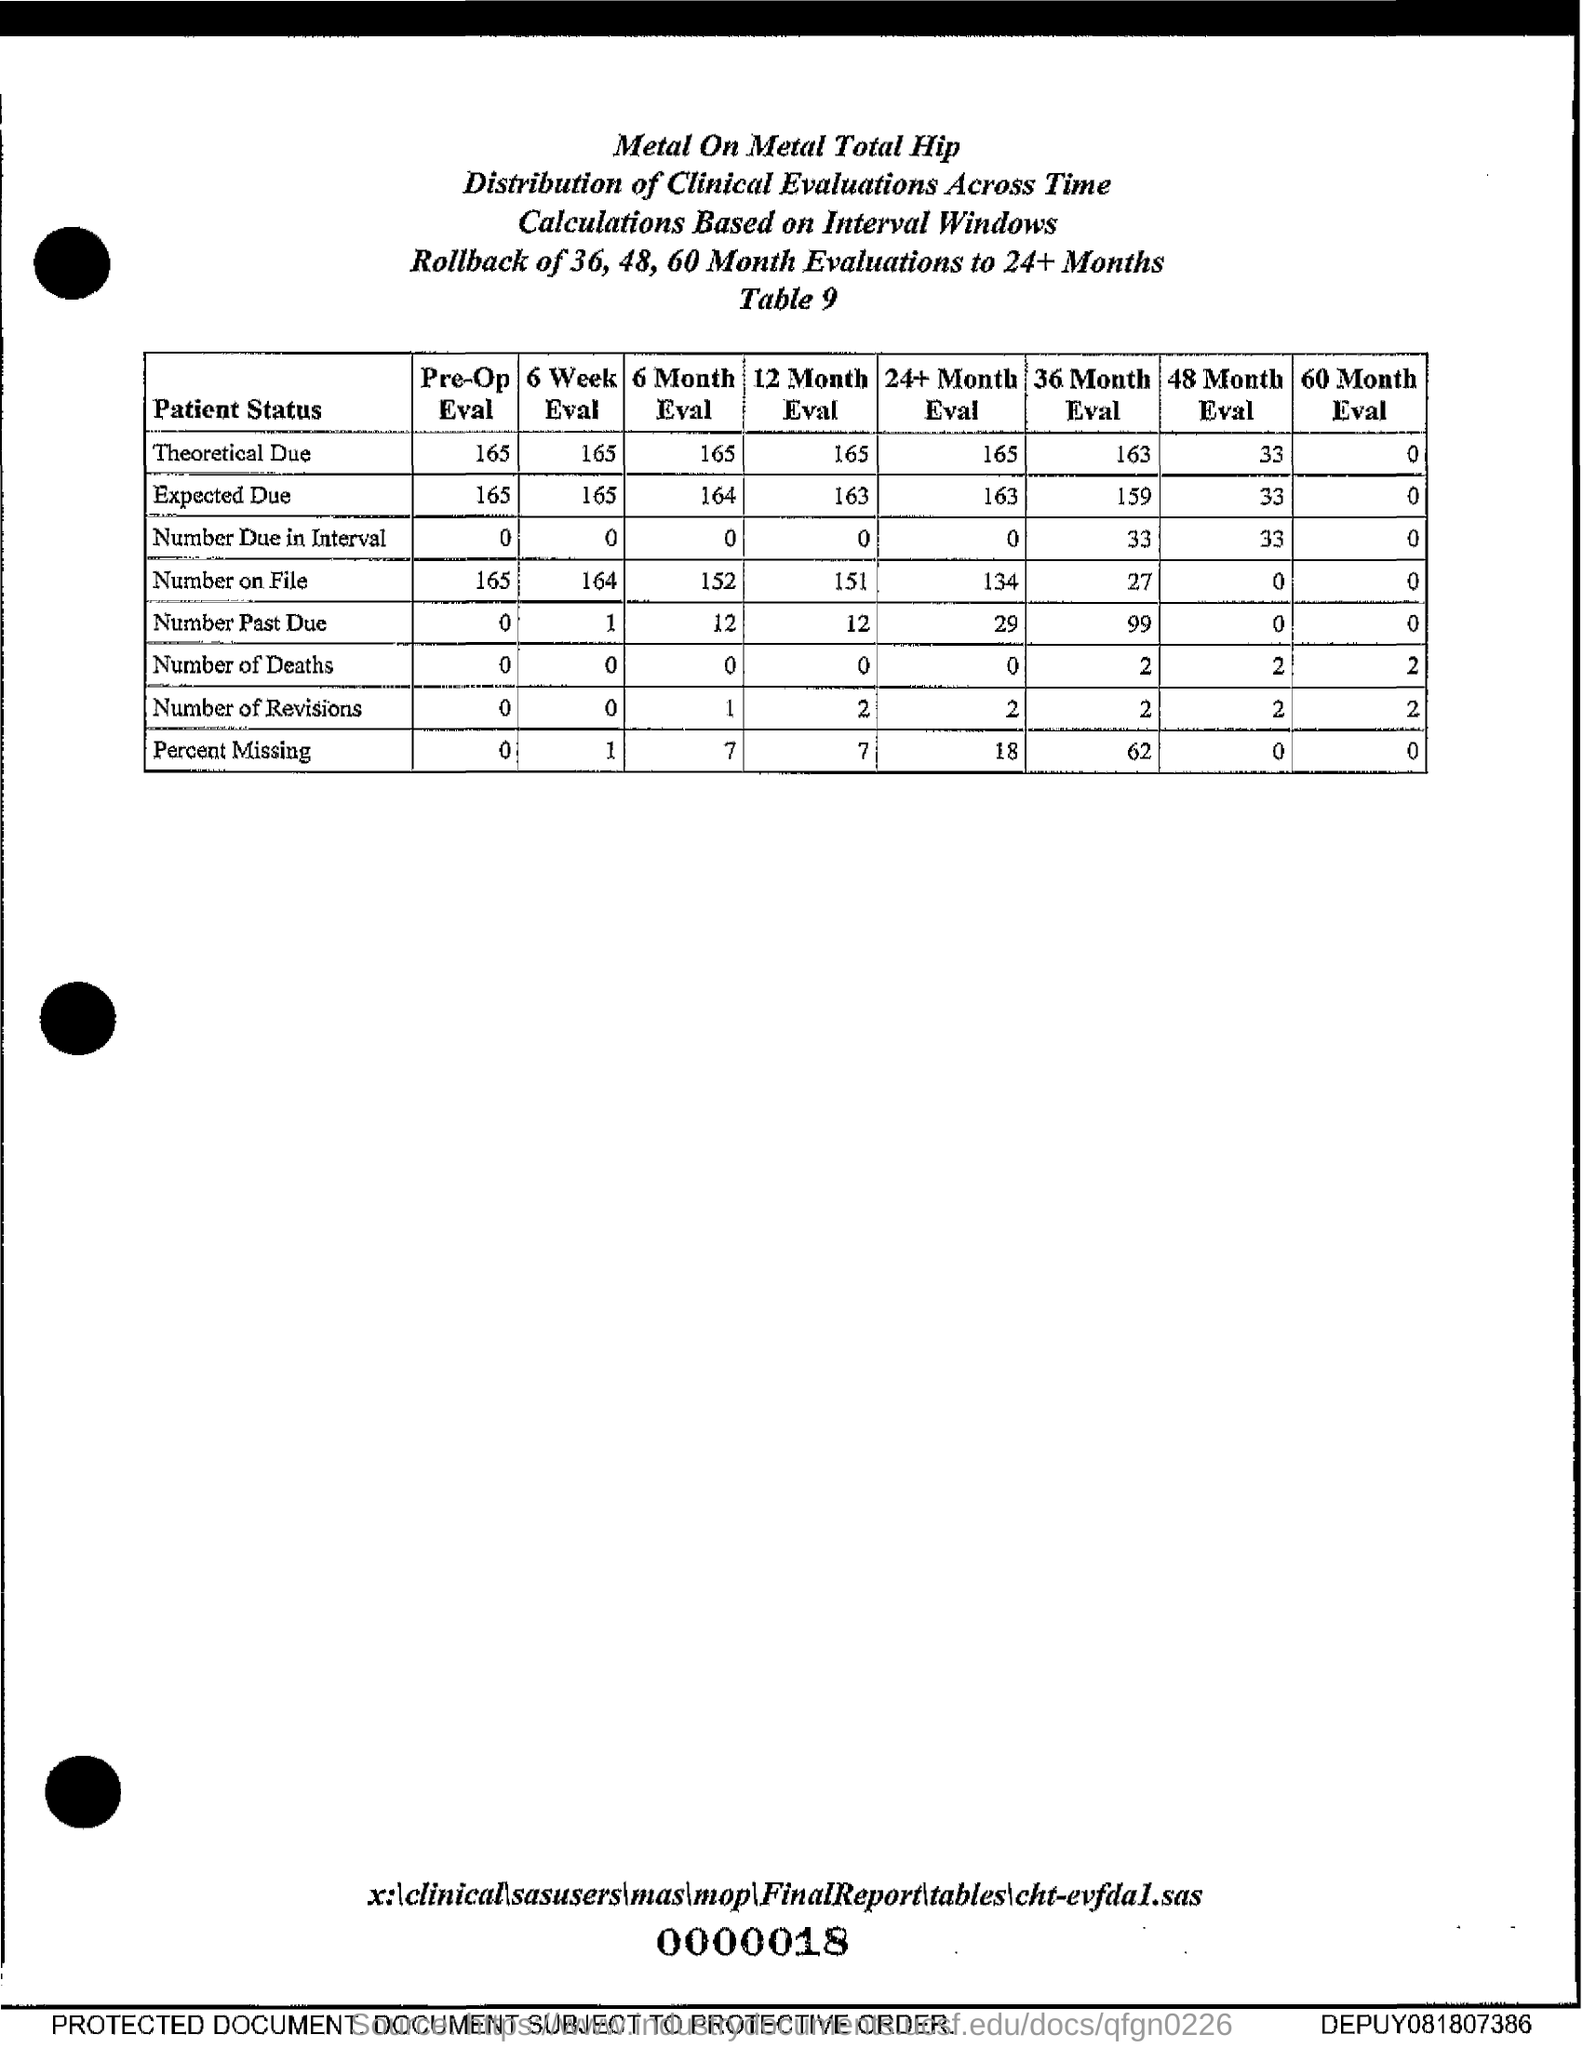What is the Pre-Op Eval for Theoretical Due?
Your answer should be very brief. 165. What is the Pre-Op Eval for Expected Due?
Make the answer very short. 165. What is the Pre-Op Eval for Number Due In Interval?
Your response must be concise. 0. What is the Pre-Op Eval for Number on File?
Your response must be concise. 165. What is the Pre-Op Eval for Number Past Due?
Give a very brief answer. 0. What is the 6 Month Eval for Number on File?
Ensure brevity in your answer.  152. What is the 6 Month Eval for Number Past Due?
Make the answer very short. 12. What is the 6 Month Eval for Number of Revisions?
Keep it short and to the point. 1. What is the 6 Month Eval for Theoretical Due?
Your response must be concise. 165. What is the 6 Month Eval for Expected Due?
Keep it short and to the point. 164. 